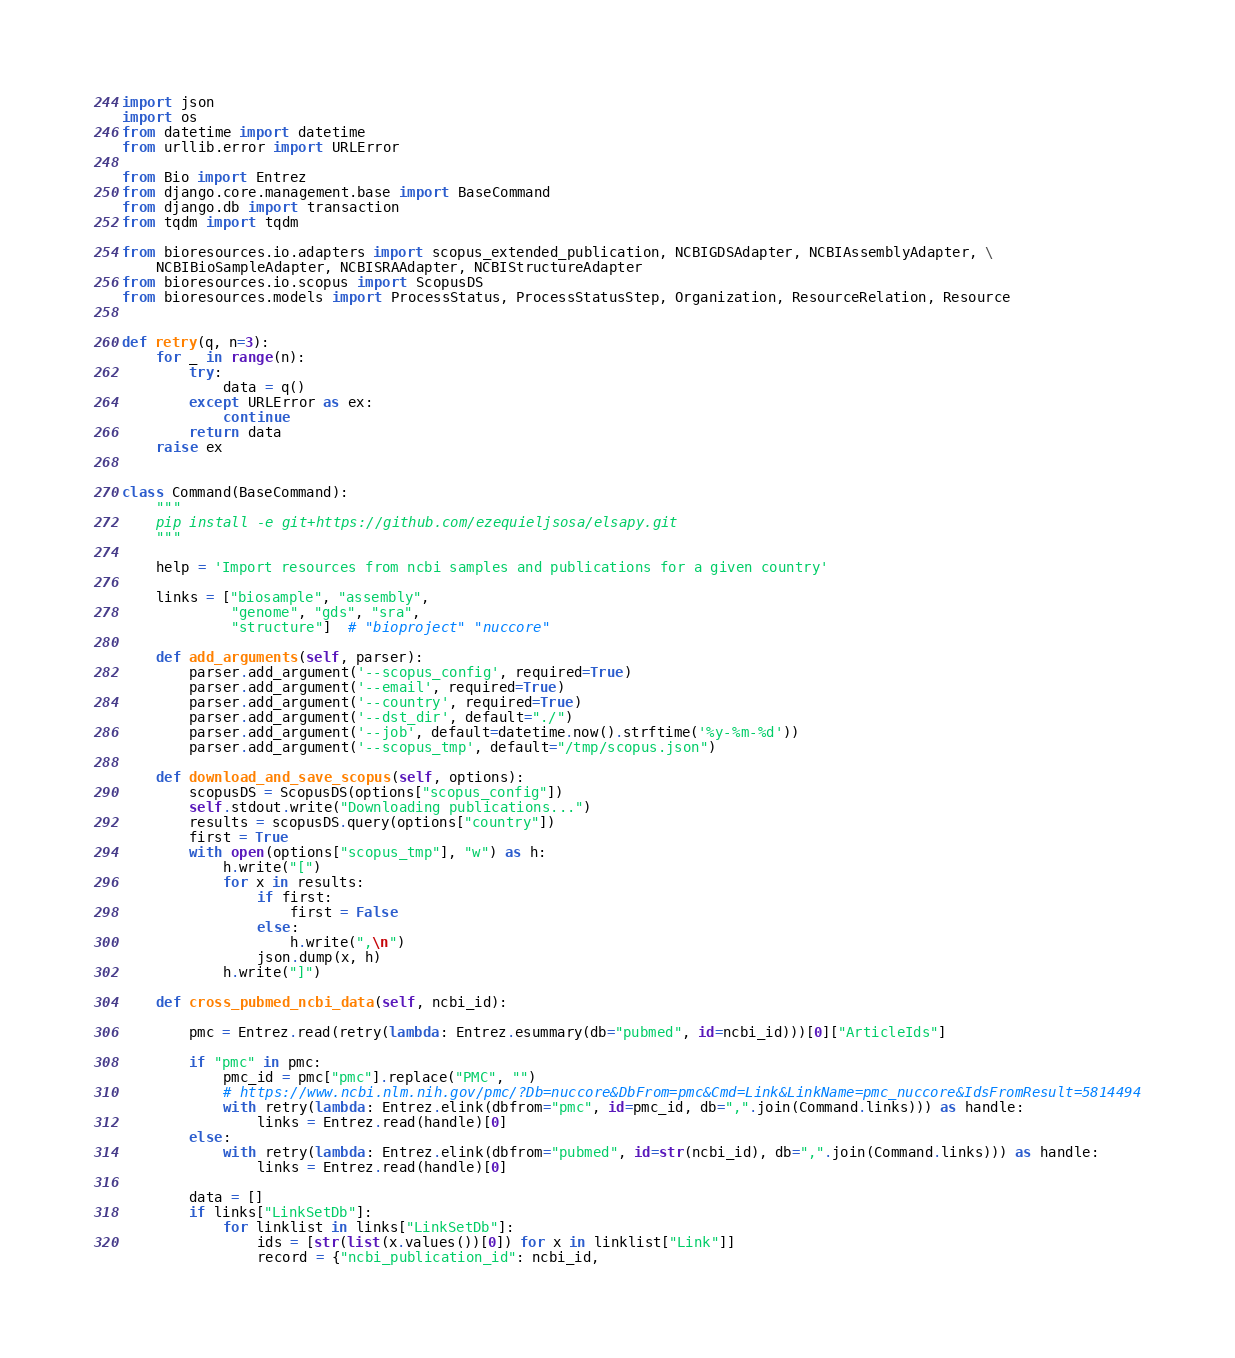<code> <loc_0><loc_0><loc_500><loc_500><_Python_>import json
import os
from datetime import datetime
from urllib.error import URLError

from Bio import Entrez
from django.core.management.base import BaseCommand
from django.db import transaction
from tqdm import tqdm

from bioresources.io.adapters import scopus_extended_publication, NCBIGDSAdapter, NCBIAssemblyAdapter, \
    NCBIBioSampleAdapter, NCBISRAAdapter, NCBIStructureAdapter
from bioresources.io.scopus import ScopusDS
from bioresources.models import ProcessStatus, ProcessStatusStep, Organization, ResourceRelation, Resource


def retry(q, n=3):
    for _ in range(n):
        try:
            data = q()
        except URLError as ex:
            continue
        return data
    raise ex


class Command(BaseCommand):
    """
    pip install -e git+https://github.com/ezequieljsosa/elsapy.git
    """

    help = 'Import resources from ncbi samples and publications for a given country'

    links = ["biosample", "assembly",
             "genome", "gds", "sra",
             "structure"]  # "bioproject" "nuccore"

    def add_arguments(self, parser):
        parser.add_argument('--scopus_config', required=True)
        parser.add_argument('--email', required=True)
        parser.add_argument('--country', required=True)
        parser.add_argument('--dst_dir', default="./")
        parser.add_argument('--job', default=datetime.now().strftime('%y-%m-%d'))
        parser.add_argument('--scopus_tmp', default="/tmp/scopus.json")

    def download_and_save_scopus(self, options):
        scopusDS = ScopusDS(options["scopus_config"])
        self.stdout.write("Downloading publications...")
        results = scopusDS.query(options["country"])
        first = True
        with open(options["scopus_tmp"], "w") as h:
            h.write("[")
            for x in results:
                if first:
                    first = False
                else:
                    h.write(",\n")
                json.dump(x, h)
            h.write("]")

    def cross_pubmed_ncbi_data(self, ncbi_id):

        pmc = Entrez.read(retry(lambda: Entrez.esummary(db="pubmed", id=ncbi_id)))[0]["ArticleIds"]

        if "pmc" in pmc:
            pmc_id = pmc["pmc"].replace("PMC", "")
            # https://www.ncbi.nlm.nih.gov/pmc/?Db=nuccore&DbFrom=pmc&Cmd=Link&LinkName=pmc_nuccore&IdsFromResult=5814494
            with retry(lambda: Entrez.elink(dbfrom="pmc", id=pmc_id, db=",".join(Command.links))) as handle:
                links = Entrez.read(handle)[0]
        else:
            with retry(lambda: Entrez.elink(dbfrom="pubmed", id=str(ncbi_id), db=",".join(Command.links))) as handle:
                links = Entrez.read(handle)[0]

        data = []
        if links["LinkSetDb"]:
            for linklist in links["LinkSetDb"]:
                ids = [str(list(x.values())[0]) for x in linklist["Link"]]
                record = {"ncbi_publication_id": ncbi_id,</code> 